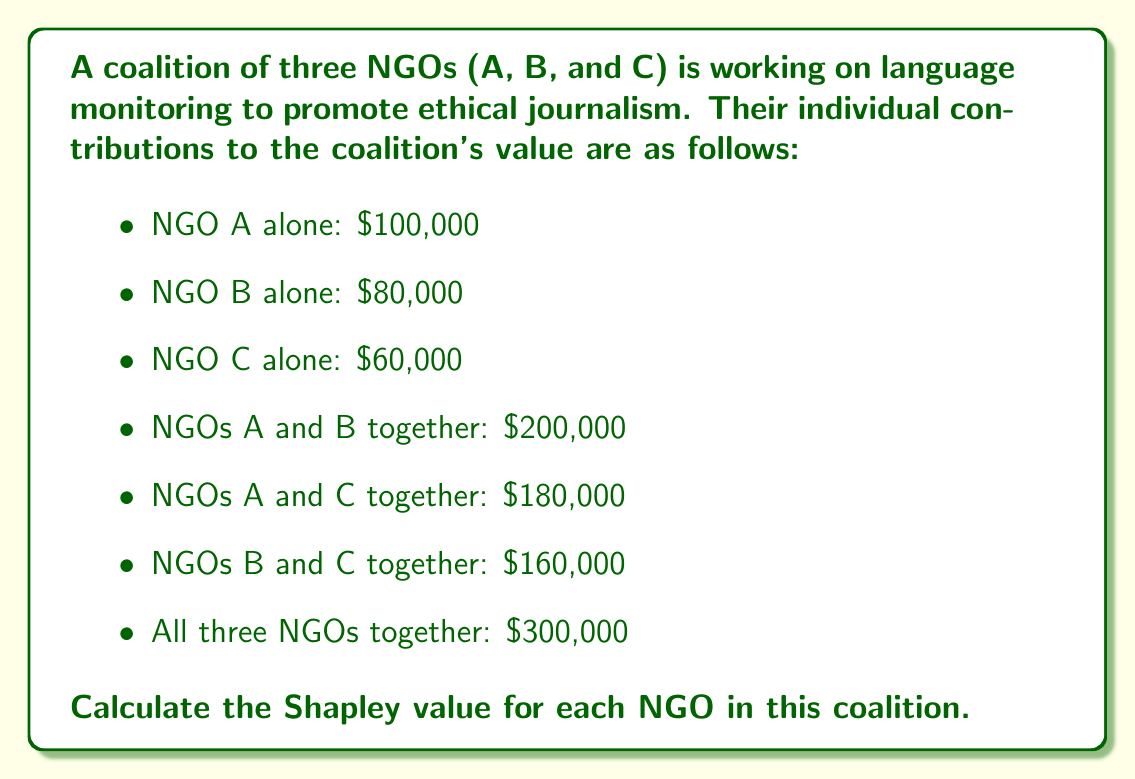Help me with this question. To calculate the Shapley value for each NGO, we need to consider all possible permutations of the coalition formation and calculate the marginal contribution of each NGO in each permutation. Then, we average these contributions.

There are 3! = 6 possible permutations:
1. A, B, C
2. A, C, B
3. B, A, C
4. B, C, A
5. C, A, B
6. C, B, A

Let's calculate the marginal contributions for each NGO in each permutation:

1. A, B, C:
   A: $100,000, B: $100,000, C: $100,000
2. A, C, B:
   A: $100,000, C: $80,000, B: $120,000
3. B, A, C:
   B: $80,000, A: $120,000, C: $100,000
4. B, C, A:
   B: $80,000, C: $80,000, A: $140,000
5. C, A, B:
   C: $60,000, A: $120,000, B: $120,000
6. C, B, A:
   C: $60,000, B: $100,000, A: $140,000

Now, we sum up the marginal contributions for each NGO and divide by 6 to get the Shapley value:

NGO A: $\frac{100,000 + 100,000 + 120,000 + 140,000 + 120,000 + 140,000}{6} = \frac{720,000}{6} = $120,000

NGO B: $\frac{100,000 + 120,000 + 80,000 + 80,000 + 120,000 + 100,000}{6} = \frac{600,000}{6} = $100,000

NGO C: $\frac{100,000 + 80,000 + 100,000 + 80,000 + 60,000 + 60,000}{6} = \frac{480,000}{6} = $80,000

We can verify that the sum of Shapley values equals the total coalition value:
$120,000 + $100,000 + $80,000 = $300,000
Answer: The Shapley values for the NGOs are:
NGO A: $120,000
NGO B: $100,000
NGO C: $80,000 